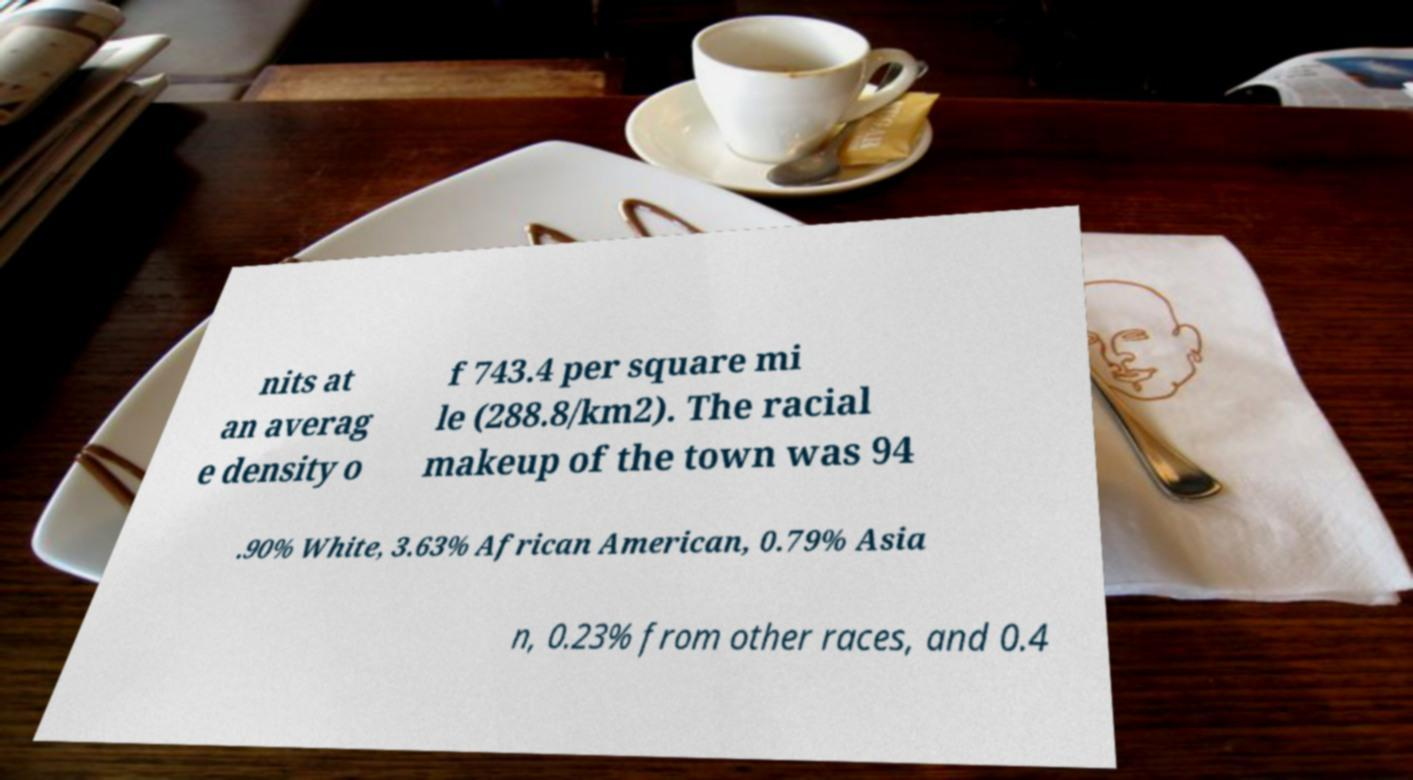Can you accurately transcribe the text from the provided image for me? nits at an averag e density o f 743.4 per square mi le (288.8/km2). The racial makeup of the town was 94 .90% White, 3.63% African American, 0.79% Asia n, 0.23% from other races, and 0.4 